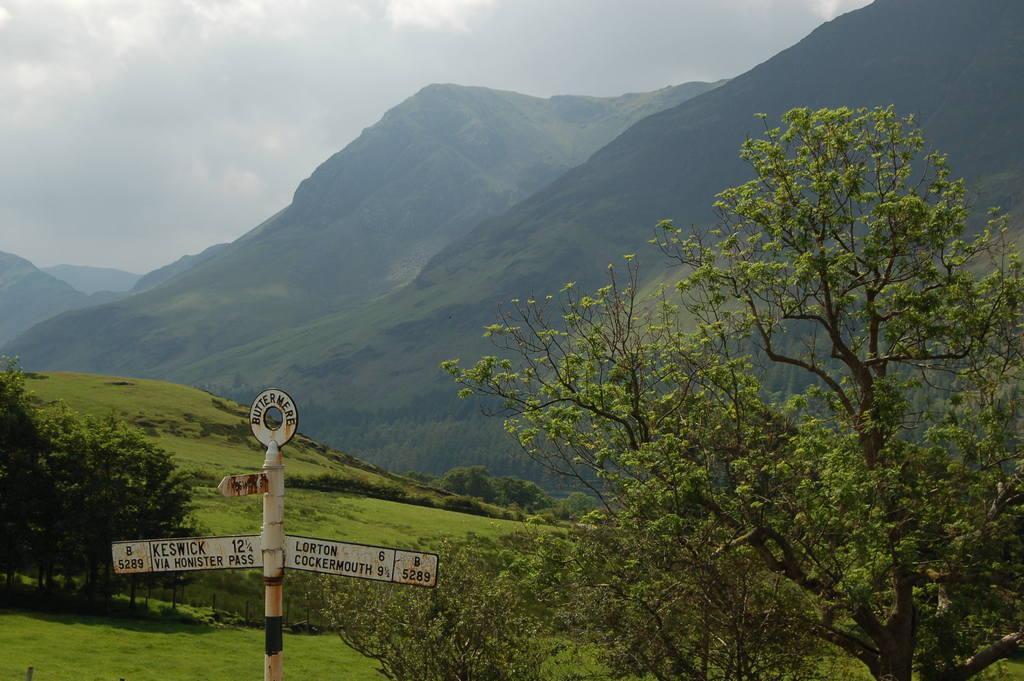Please provide a concise description of this image. In this picture we can see name boards attached to a pole, trees, mountains, grass and in the background we can see the sky with clouds. 